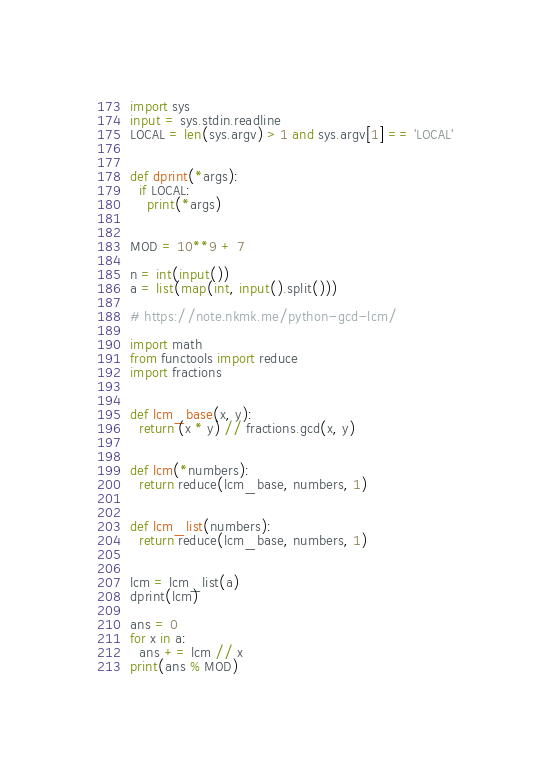<code> <loc_0><loc_0><loc_500><loc_500><_Python_>import sys
input = sys.stdin.readline
LOCAL = len(sys.argv) > 1 and sys.argv[1] == 'LOCAL'


def dprint(*args):
  if LOCAL:
    print(*args)


MOD = 10**9 + 7

n = int(input())
a = list(map(int, input().split()))

# https://note.nkmk.me/python-gcd-lcm/

import math
from functools import reduce
import fractions


def lcm_base(x, y):
  return (x * y) // fractions.gcd(x, y)


def lcm(*numbers):
  return reduce(lcm_base, numbers, 1)


def lcm_list(numbers):
  return reduce(lcm_base, numbers, 1)


lcm = lcm_list(a)
dprint(lcm)

ans = 0
for x in a:
  ans += lcm // x
print(ans % MOD)
</code> 